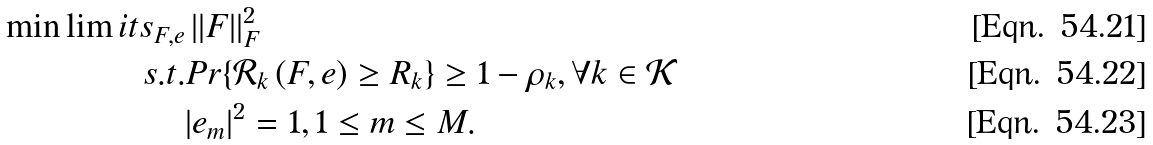<formula> <loc_0><loc_0><loc_500><loc_500>\min \lim i t s _ { F , e } & \, | | F | | _ { F } ^ { 2 } \\ s . t . & P r \{ \mathcal { R } _ { k } \left ( F , e \right ) \geq R _ { k } \} \geq 1 - \rho _ { k } , \forall k \in \mathcal { K } \\ & | e _ { m } | ^ { 2 } = 1 , 1 \leq m \leq M .</formula> 